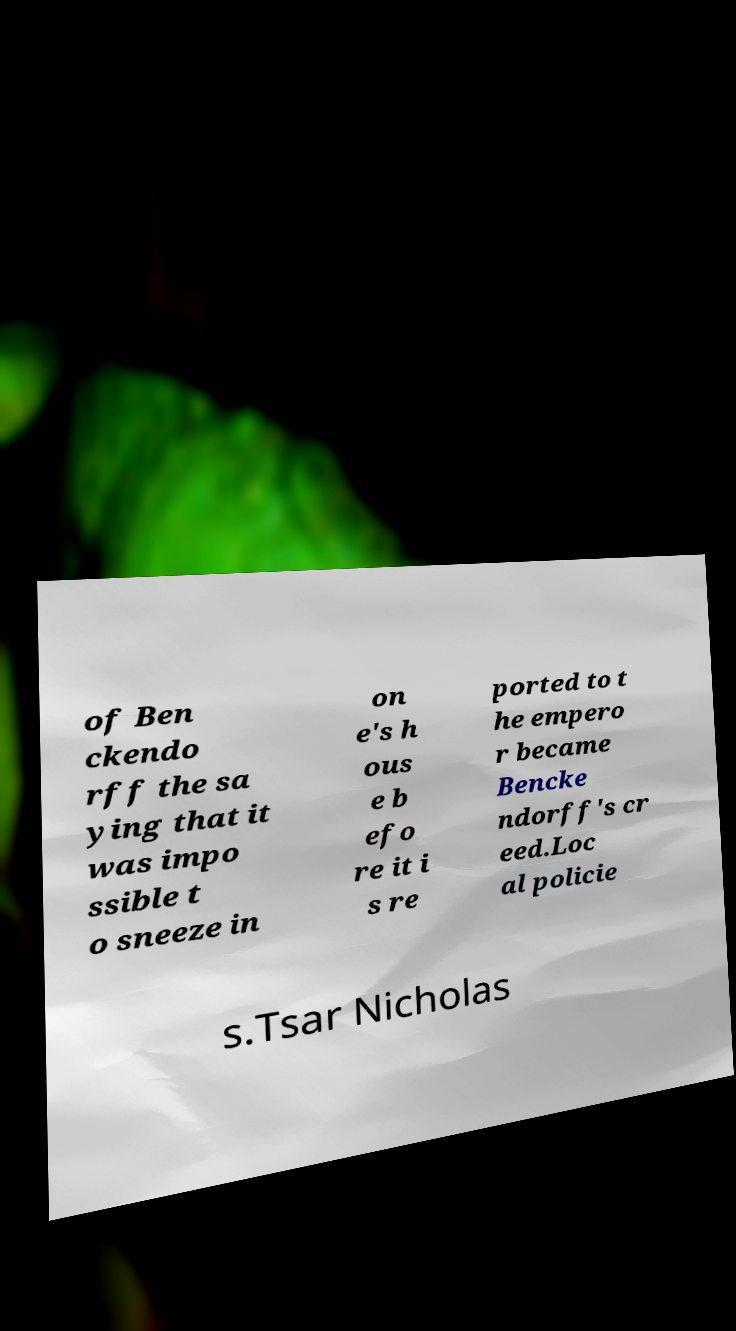Can you read and provide the text displayed in the image?This photo seems to have some interesting text. Can you extract and type it out for me? of Ben ckendo rff the sa ying that it was impo ssible t o sneeze in on e's h ous e b efo re it i s re ported to t he empero r became Bencke ndorff's cr eed.Loc al policie s.Tsar Nicholas 